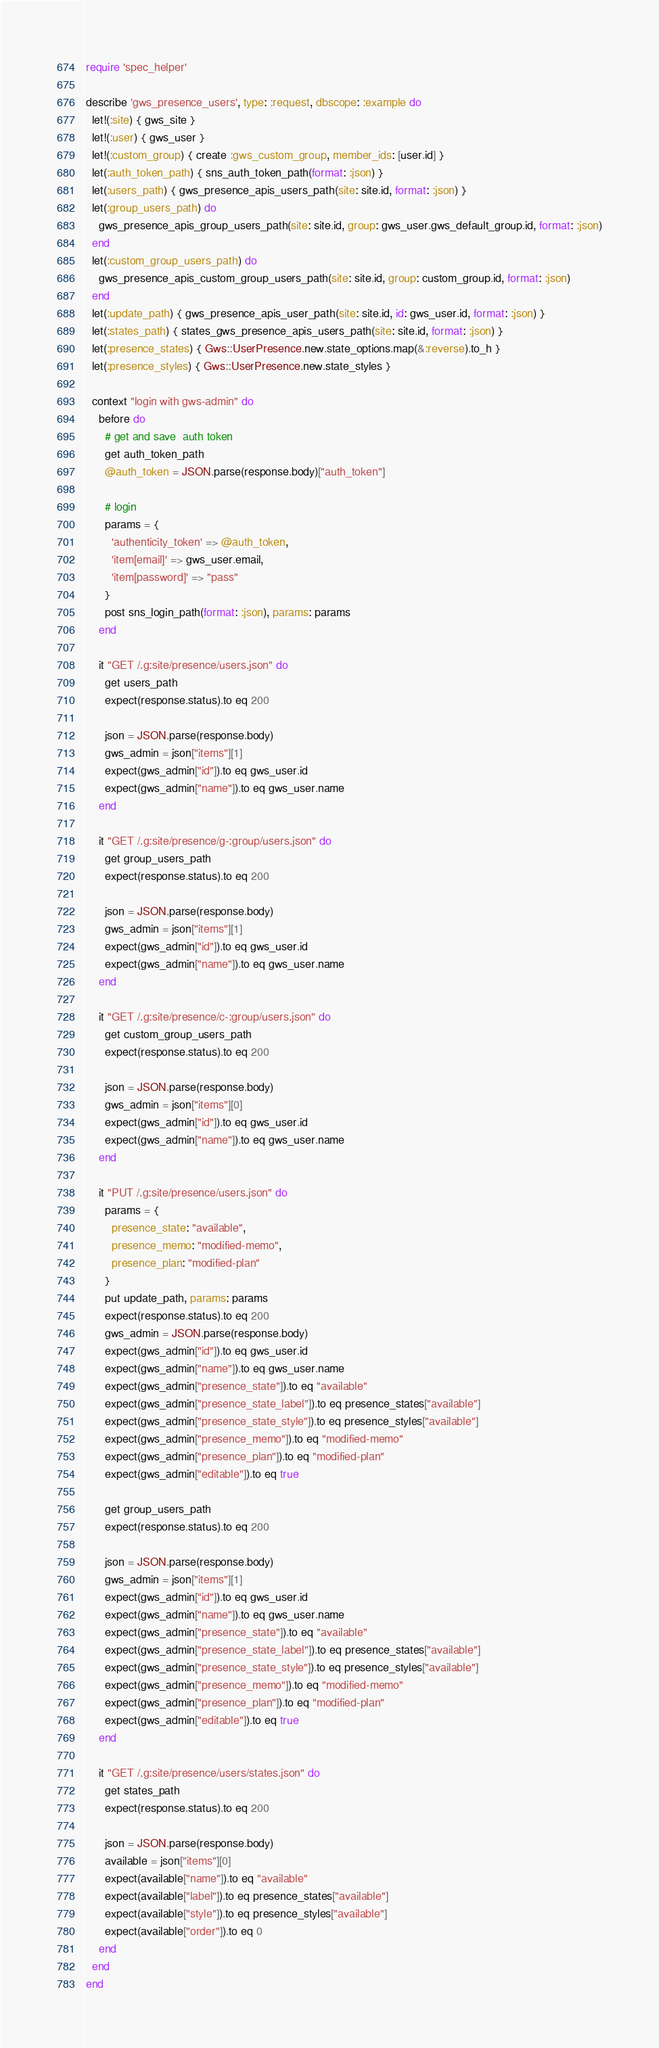Convert code to text. <code><loc_0><loc_0><loc_500><loc_500><_Ruby_>require 'spec_helper'

describe 'gws_presence_users', type: :request, dbscope: :example do
  let!(:site) { gws_site }
  let!(:user) { gws_user }
  let!(:custom_group) { create :gws_custom_group, member_ids: [user.id] }
  let(:auth_token_path) { sns_auth_token_path(format: :json) }
  let(:users_path) { gws_presence_apis_users_path(site: site.id, format: :json) }
  let(:group_users_path) do
    gws_presence_apis_group_users_path(site: site.id, group: gws_user.gws_default_group.id, format: :json)
  end
  let(:custom_group_users_path) do
    gws_presence_apis_custom_group_users_path(site: site.id, group: custom_group.id, format: :json)
  end
  let(:update_path) { gws_presence_apis_user_path(site: site.id, id: gws_user.id, format: :json) }
  let(:states_path) { states_gws_presence_apis_users_path(site: site.id, format: :json) }
  let(:presence_states) { Gws::UserPresence.new.state_options.map(&:reverse).to_h }
  let(:presence_styles) { Gws::UserPresence.new.state_styles }

  context "login with gws-admin" do
    before do
      # get and save  auth token
      get auth_token_path
      @auth_token = JSON.parse(response.body)["auth_token"]

      # login
      params = {
        'authenticity_token' => @auth_token,
        'item[email]' => gws_user.email,
        'item[password]' => "pass"
      }
      post sns_login_path(format: :json), params: params
    end

    it "GET /.g:site/presence/users.json" do
      get users_path
      expect(response.status).to eq 200

      json = JSON.parse(response.body)
      gws_admin = json["items"][1]
      expect(gws_admin["id"]).to eq gws_user.id
      expect(gws_admin["name"]).to eq gws_user.name
    end

    it "GET /.g:site/presence/g-:group/users.json" do
      get group_users_path
      expect(response.status).to eq 200

      json = JSON.parse(response.body)
      gws_admin = json["items"][1]
      expect(gws_admin["id"]).to eq gws_user.id
      expect(gws_admin["name"]).to eq gws_user.name
    end

    it "GET /.g:site/presence/c-:group/users.json" do
      get custom_group_users_path
      expect(response.status).to eq 200

      json = JSON.parse(response.body)
      gws_admin = json["items"][0]
      expect(gws_admin["id"]).to eq gws_user.id
      expect(gws_admin["name"]).to eq gws_user.name
    end

    it "PUT /.g:site/presence/users.json" do
      params = {
        presence_state: "available",
        presence_memo: "modified-memo",
        presence_plan: "modified-plan"
      }
      put update_path, params: params
      expect(response.status).to eq 200
      gws_admin = JSON.parse(response.body)
      expect(gws_admin["id"]).to eq gws_user.id
      expect(gws_admin["name"]).to eq gws_user.name
      expect(gws_admin["presence_state"]).to eq "available"
      expect(gws_admin["presence_state_label"]).to eq presence_states["available"]
      expect(gws_admin["presence_state_style"]).to eq presence_styles["available"]
      expect(gws_admin["presence_memo"]).to eq "modified-memo"
      expect(gws_admin["presence_plan"]).to eq "modified-plan"
      expect(gws_admin["editable"]).to eq true

      get group_users_path
      expect(response.status).to eq 200

      json = JSON.parse(response.body)
      gws_admin = json["items"][1]
      expect(gws_admin["id"]).to eq gws_user.id
      expect(gws_admin["name"]).to eq gws_user.name
      expect(gws_admin["presence_state"]).to eq "available"
      expect(gws_admin["presence_state_label"]).to eq presence_states["available"]
      expect(gws_admin["presence_state_style"]).to eq presence_styles["available"]
      expect(gws_admin["presence_memo"]).to eq "modified-memo"
      expect(gws_admin["presence_plan"]).to eq "modified-plan"
      expect(gws_admin["editable"]).to eq true
    end

    it "GET /.g:site/presence/users/states.json" do
      get states_path
      expect(response.status).to eq 200

      json = JSON.parse(response.body)
      available = json["items"][0]
      expect(available["name"]).to eq "available"
      expect(available["label"]).to eq presence_states["available"]
      expect(available["style"]).to eq presence_styles["available"]
      expect(available["order"]).to eq 0
    end
  end
end
</code> 